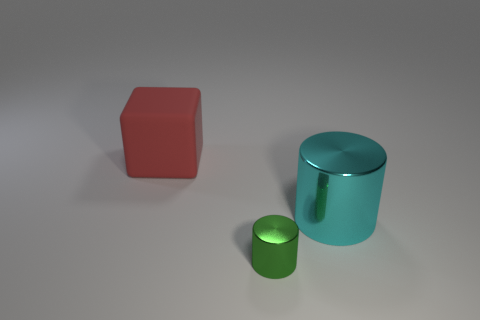Add 1 small green metal things. How many objects exist? 4 Subtract all blocks. How many objects are left? 2 Add 1 tiny green objects. How many tiny green objects exist? 2 Subtract 0 purple cylinders. How many objects are left? 3 Subtract all large blue shiny objects. Subtract all green things. How many objects are left? 2 Add 3 red rubber objects. How many red rubber objects are left? 4 